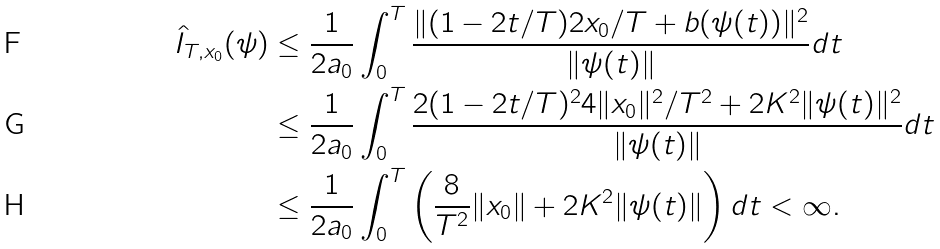Convert formula to latex. <formula><loc_0><loc_0><loc_500><loc_500>\hat { I } _ { T , x _ { 0 } } ( \psi ) & \leq \frac { 1 } { 2 a _ { 0 } } \int _ { 0 } ^ { T } \frac { \| ( 1 - 2 t / T ) 2 x _ { 0 } / T + b ( \psi ( t ) ) \| ^ { 2 } } { \| \psi ( t ) \| } d t \\ & \leq \frac { 1 } { 2 a _ { 0 } } \int _ { 0 } ^ { T } \frac { 2 ( 1 - 2 t / T ) ^ { 2 } 4 \| x _ { 0 } \| ^ { 2 } / T ^ { 2 } + 2 K ^ { 2 } \| \psi ( t ) \| ^ { 2 } } { \| \psi ( t ) \| } d t \\ & \leq \frac { 1 } { 2 a _ { 0 } } \int _ { 0 } ^ { T } \left ( \frac { 8 } { T ^ { 2 } } \| x _ { 0 } \| + 2 K ^ { 2 } \| \psi ( t ) \| \right ) d t < \infty .</formula> 